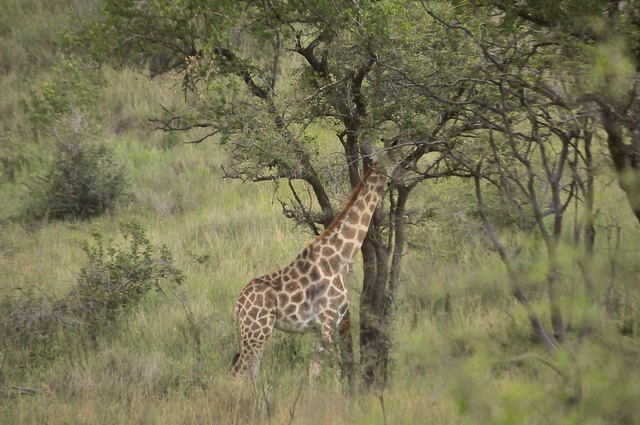Describe the objects in this image and their specific colors. I can see a giraffe in olive, gray, and tan tones in this image. 